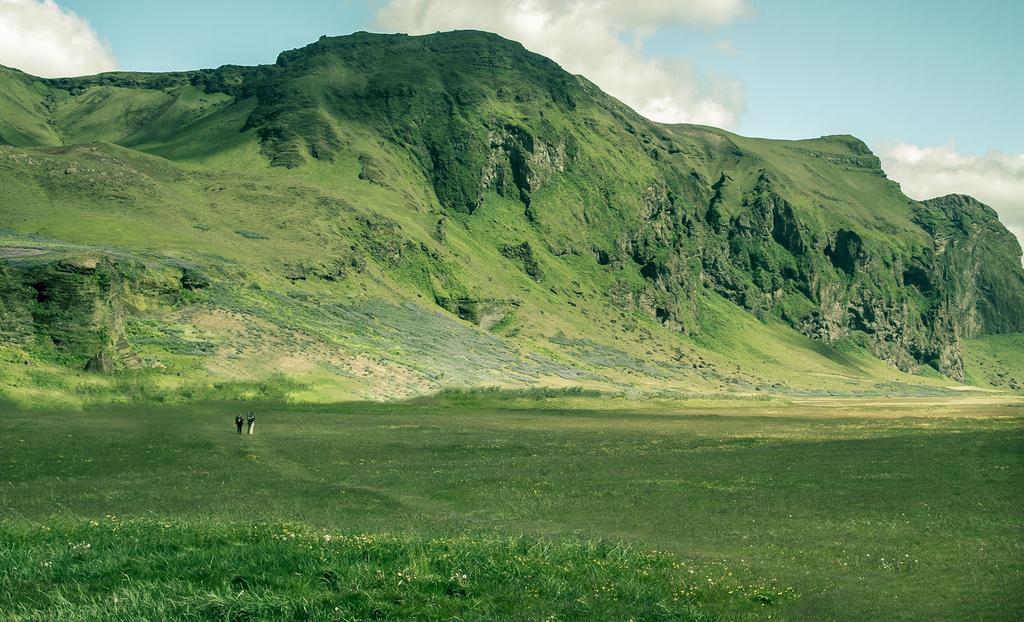How would you summarize this image in a sentence or two? In this image there are hills and sky. At the bottom there is grass and we can see people. 